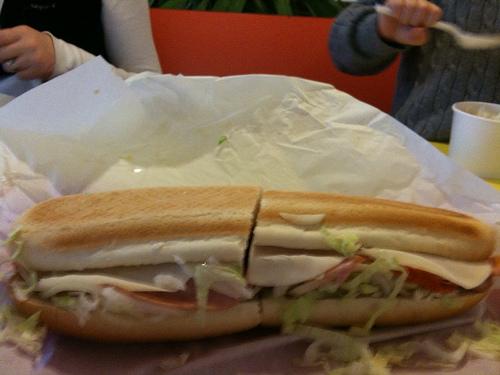How is the sandwich cut?
Short answer required. In half. Has anyone taken a bite of the sandwich yet?
Give a very brief answer. No. Is there lettuce on the sandwich?
Concise answer only. Yes. What color is the basket holding the food?
Concise answer only. White. 